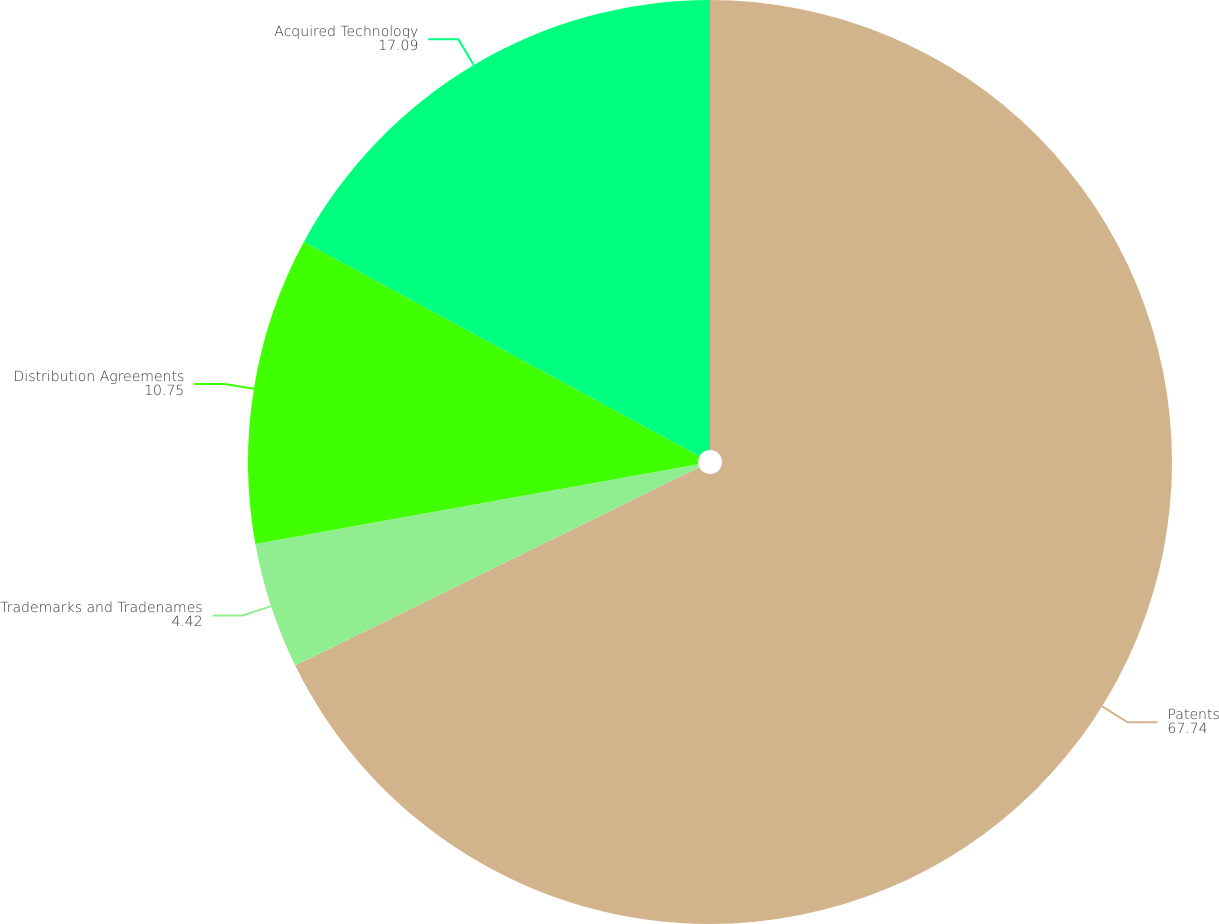Convert chart to OTSL. <chart><loc_0><loc_0><loc_500><loc_500><pie_chart><fcel>Patents<fcel>Trademarks and Tradenames<fcel>Distribution Agreements<fcel>Acquired Technology<nl><fcel>67.74%<fcel>4.42%<fcel>10.75%<fcel>17.09%<nl></chart> 